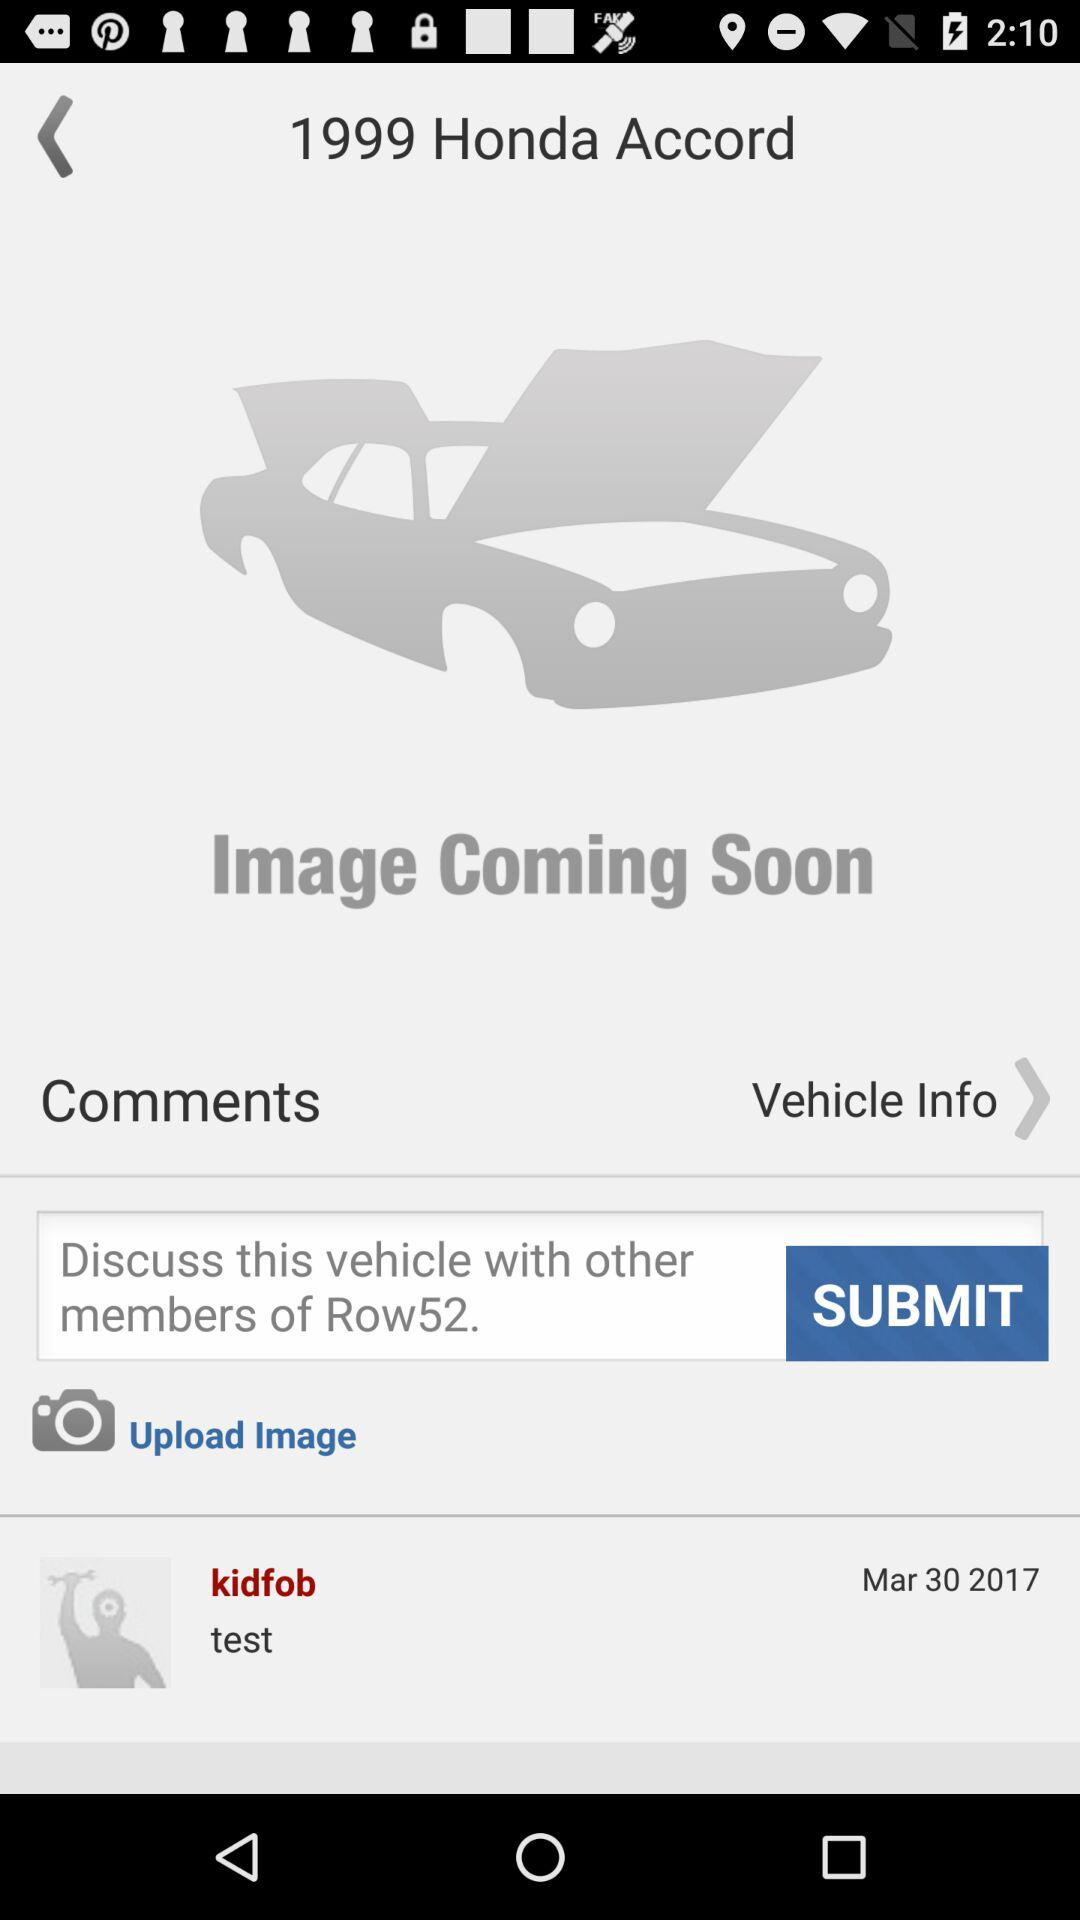What is the name of the vehicle? The name of the vehicle is "Honda Accord". 